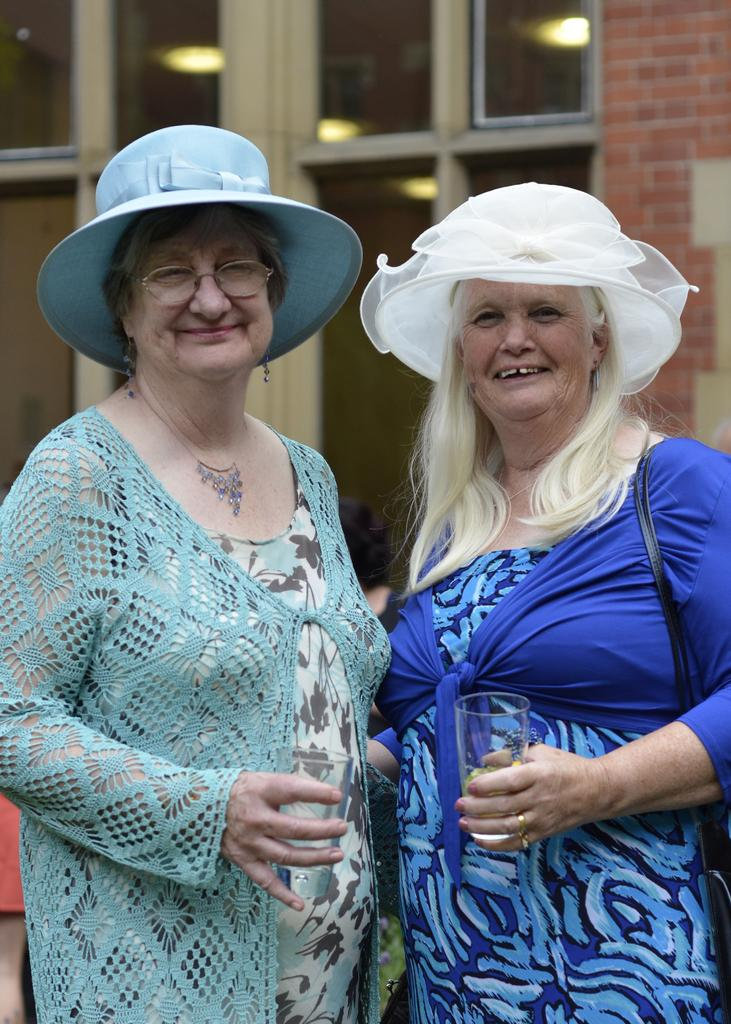How many people are in the image? There are two women in the image. What are the women holding in their hands? The women are holding glasses in their hands. What type of accessory are the women wearing on their heads? The women are wearing hats in the image. What type of pipe can be seen in the image? There is no pipe present in the image. Are the women swimming in the image? There is no indication in the image that the women are swimming. 